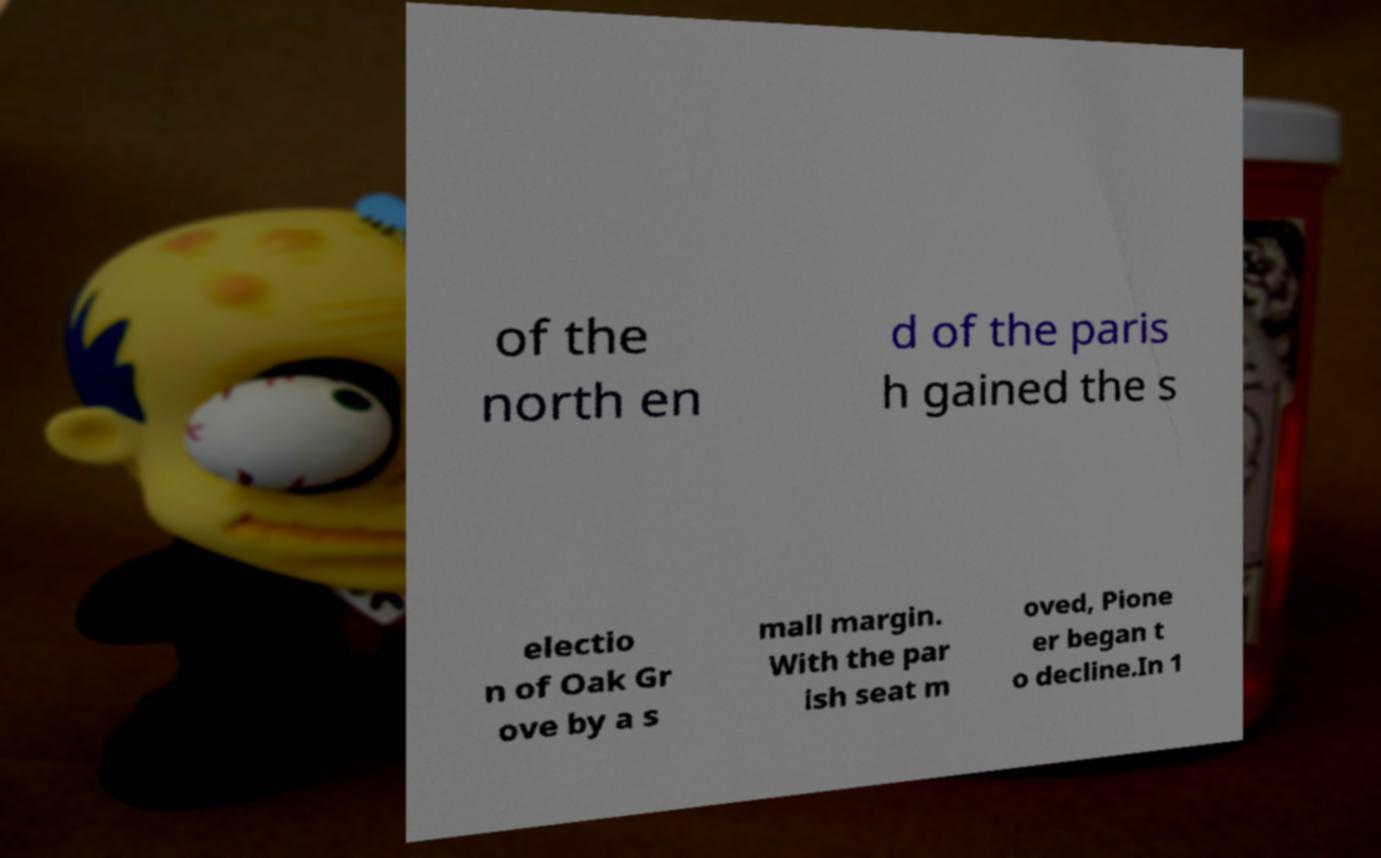What messages or text are displayed in this image? I need them in a readable, typed format. of the north en d of the paris h gained the s electio n of Oak Gr ove by a s mall margin. With the par ish seat m oved, Pione er began t o decline.In 1 